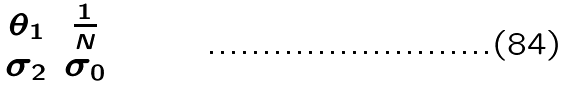<formula> <loc_0><loc_0><loc_500><loc_500>\begin{matrix} \theta _ { 1 } & \frac { 1 } { N } \\ \sigma _ { 2 } & \sigma _ { 0 } \end{matrix}</formula> 